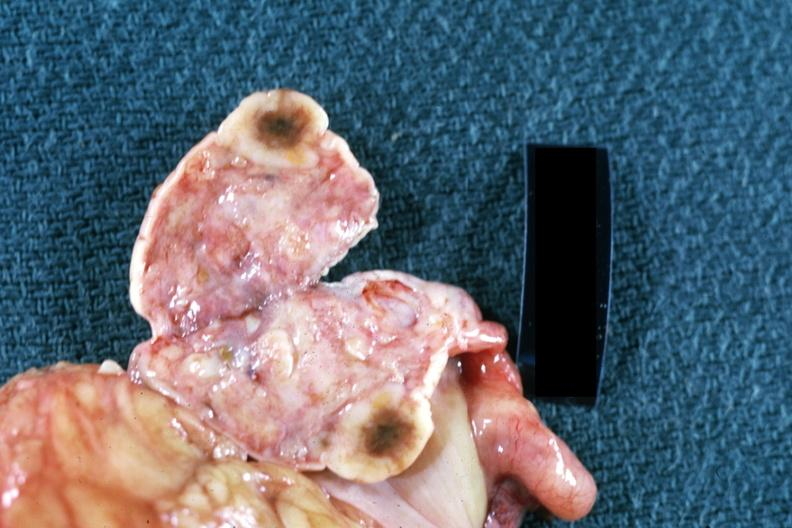what is present?
Answer the question using a single word or phrase. Female reproductive 